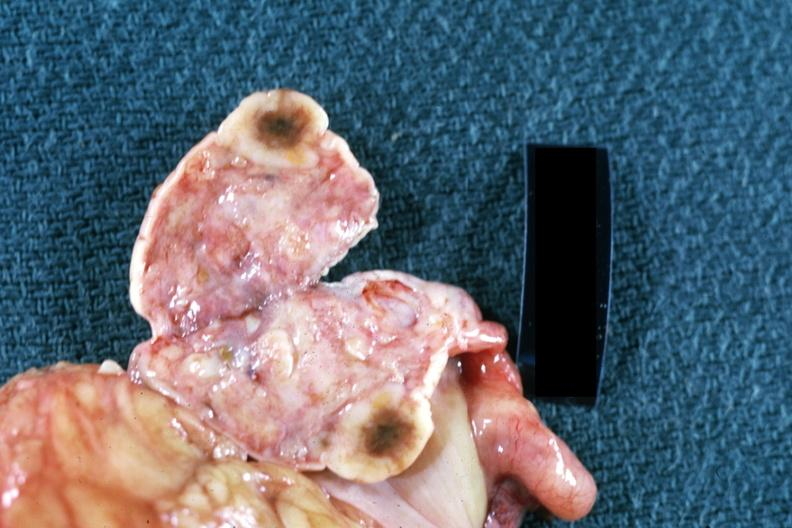what is present?
Answer the question using a single word or phrase. Female reproductive 